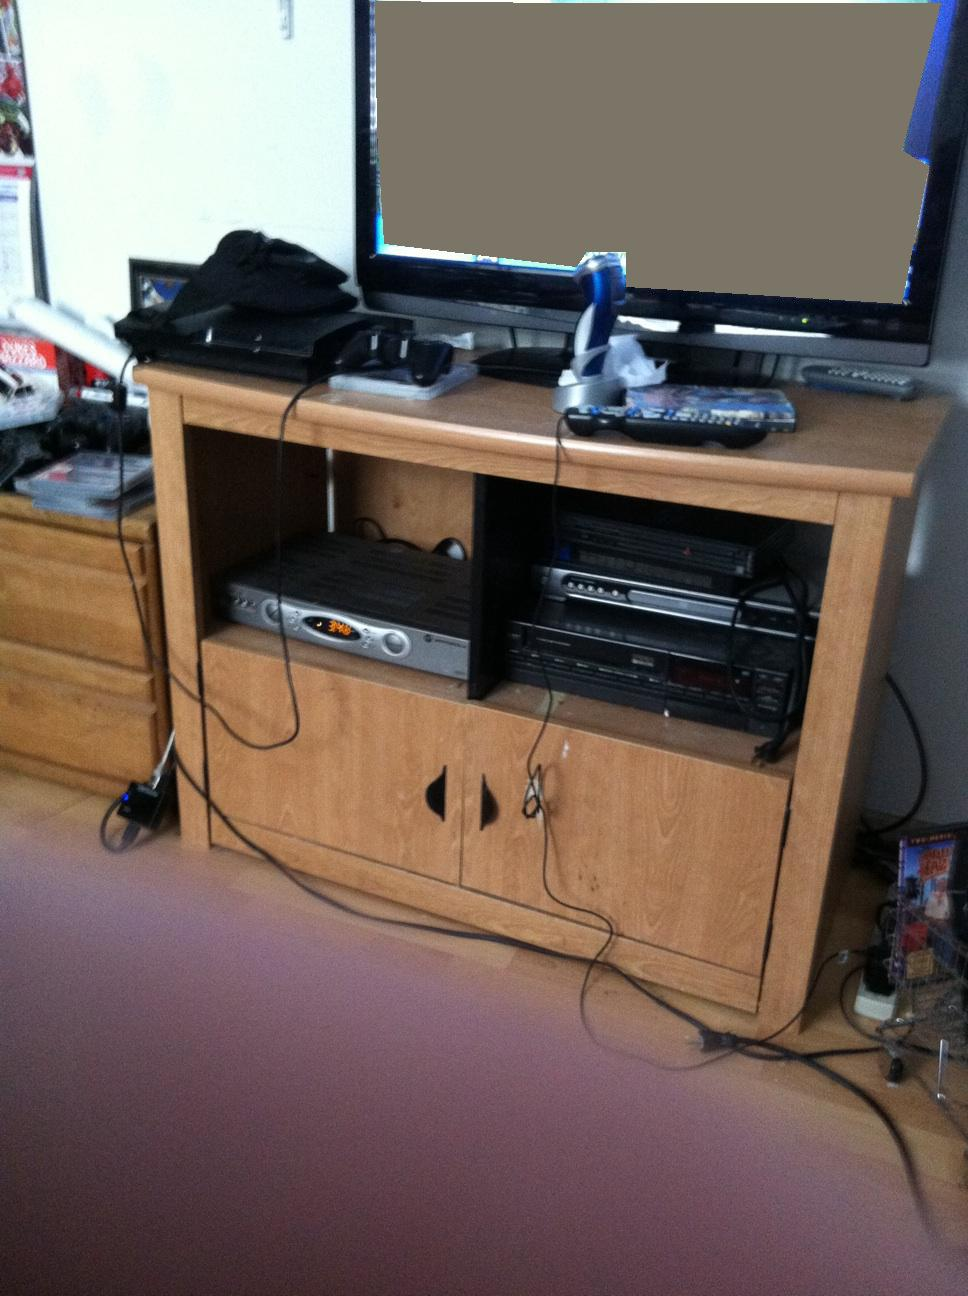What time is it in Eastern daylight time? It's not possible to determine the current time in Eastern Daylight Time from the image as there are no visible clocks or other time-indicating elements. Additionally, time information needs real-time data which the image cannot provide. 